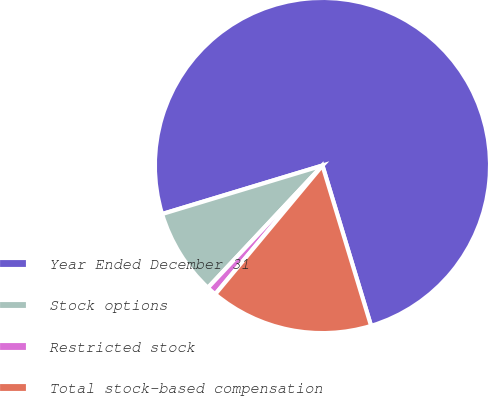Convert chart. <chart><loc_0><loc_0><loc_500><loc_500><pie_chart><fcel>Year Ended December 31<fcel>Stock options<fcel>Restricted stock<fcel>Total stock-based compensation<nl><fcel>74.99%<fcel>8.34%<fcel>0.93%<fcel>15.74%<nl></chart> 